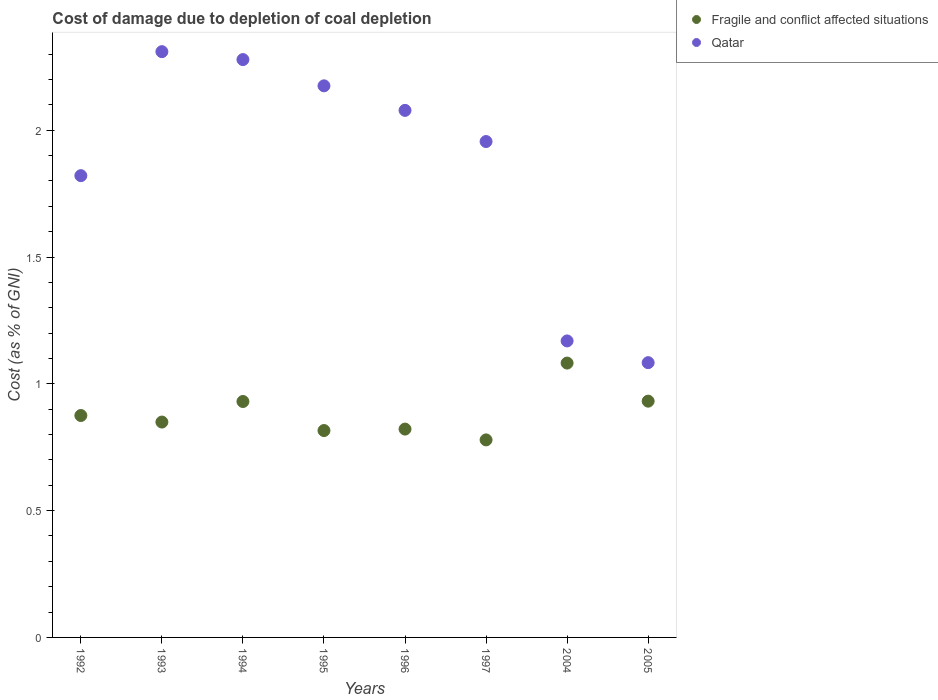How many different coloured dotlines are there?
Keep it short and to the point. 2. What is the cost of damage caused due to coal depletion in Fragile and conflict affected situations in 1994?
Offer a very short reply. 0.93. Across all years, what is the maximum cost of damage caused due to coal depletion in Fragile and conflict affected situations?
Ensure brevity in your answer.  1.08. Across all years, what is the minimum cost of damage caused due to coal depletion in Qatar?
Provide a short and direct response. 1.08. In which year was the cost of damage caused due to coal depletion in Qatar minimum?
Your answer should be compact. 2005. What is the total cost of damage caused due to coal depletion in Fragile and conflict affected situations in the graph?
Offer a very short reply. 7.08. What is the difference between the cost of damage caused due to coal depletion in Qatar in 1992 and that in 1994?
Your answer should be compact. -0.46. What is the difference between the cost of damage caused due to coal depletion in Qatar in 1994 and the cost of damage caused due to coal depletion in Fragile and conflict affected situations in 1992?
Give a very brief answer. 1.4. What is the average cost of damage caused due to coal depletion in Fragile and conflict affected situations per year?
Your response must be concise. 0.89. In the year 2005, what is the difference between the cost of damage caused due to coal depletion in Fragile and conflict affected situations and cost of damage caused due to coal depletion in Qatar?
Your response must be concise. -0.15. In how many years, is the cost of damage caused due to coal depletion in Qatar greater than 0.7 %?
Ensure brevity in your answer.  8. What is the ratio of the cost of damage caused due to coal depletion in Fragile and conflict affected situations in 1994 to that in 1995?
Keep it short and to the point. 1.14. Is the difference between the cost of damage caused due to coal depletion in Fragile and conflict affected situations in 1992 and 2005 greater than the difference between the cost of damage caused due to coal depletion in Qatar in 1992 and 2005?
Your answer should be compact. No. What is the difference between the highest and the second highest cost of damage caused due to coal depletion in Fragile and conflict affected situations?
Provide a short and direct response. 0.15. What is the difference between the highest and the lowest cost of damage caused due to coal depletion in Fragile and conflict affected situations?
Give a very brief answer. 0.3. In how many years, is the cost of damage caused due to coal depletion in Qatar greater than the average cost of damage caused due to coal depletion in Qatar taken over all years?
Your answer should be compact. 5. Is the sum of the cost of damage caused due to coal depletion in Qatar in 1993 and 1997 greater than the maximum cost of damage caused due to coal depletion in Fragile and conflict affected situations across all years?
Provide a succinct answer. Yes. How many years are there in the graph?
Your response must be concise. 8. What is the difference between two consecutive major ticks on the Y-axis?
Your answer should be compact. 0.5. Where does the legend appear in the graph?
Your response must be concise. Top right. What is the title of the graph?
Provide a succinct answer. Cost of damage due to depletion of coal depletion. What is the label or title of the X-axis?
Provide a short and direct response. Years. What is the label or title of the Y-axis?
Make the answer very short. Cost (as % of GNI). What is the Cost (as % of GNI) in Fragile and conflict affected situations in 1992?
Offer a very short reply. 0.88. What is the Cost (as % of GNI) in Qatar in 1992?
Make the answer very short. 1.82. What is the Cost (as % of GNI) of Fragile and conflict affected situations in 1993?
Your answer should be very brief. 0.85. What is the Cost (as % of GNI) of Qatar in 1993?
Offer a terse response. 2.31. What is the Cost (as % of GNI) of Fragile and conflict affected situations in 1994?
Your answer should be very brief. 0.93. What is the Cost (as % of GNI) of Qatar in 1994?
Give a very brief answer. 2.28. What is the Cost (as % of GNI) in Fragile and conflict affected situations in 1995?
Your answer should be compact. 0.82. What is the Cost (as % of GNI) in Qatar in 1995?
Provide a succinct answer. 2.18. What is the Cost (as % of GNI) of Fragile and conflict affected situations in 1996?
Offer a terse response. 0.82. What is the Cost (as % of GNI) in Qatar in 1996?
Make the answer very short. 2.08. What is the Cost (as % of GNI) of Fragile and conflict affected situations in 1997?
Provide a short and direct response. 0.78. What is the Cost (as % of GNI) of Qatar in 1997?
Your answer should be compact. 1.96. What is the Cost (as % of GNI) in Fragile and conflict affected situations in 2004?
Give a very brief answer. 1.08. What is the Cost (as % of GNI) of Qatar in 2004?
Give a very brief answer. 1.17. What is the Cost (as % of GNI) in Fragile and conflict affected situations in 2005?
Your answer should be very brief. 0.93. What is the Cost (as % of GNI) in Qatar in 2005?
Make the answer very short. 1.08. Across all years, what is the maximum Cost (as % of GNI) of Fragile and conflict affected situations?
Provide a succinct answer. 1.08. Across all years, what is the maximum Cost (as % of GNI) of Qatar?
Your answer should be very brief. 2.31. Across all years, what is the minimum Cost (as % of GNI) in Fragile and conflict affected situations?
Make the answer very short. 0.78. Across all years, what is the minimum Cost (as % of GNI) in Qatar?
Offer a terse response. 1.08. What is the total Cost (as % of GNI) of Fragile and conflict affected situations in the graph?
Your answer should be very brief. 7.08. What is the total Cost (as % of GNI) in Qatar in the graph?
Ensure brevity in your answer.  14.87. What is the difference between the Cost (as % of GNI) in Fragile and conflict affected situations in 1992 and that in 1993?
Provide a short and direct response. 0.03. What is the difference between the Cost (as % of GNI) of Qatar in 1992 and that in 1993?
Ensure brevity in your answer.  -0.49. What is the difference between the Cost (as % of GNI) of Fragile and conflict affected situations in 1992 and that in 1994?
Make the answer very short. -0.06. What is the difference between the Cost (as % of GNI) in Qatar in 1992 and that in 1994?
Your answer should be compact. -0.46. What is the difference between the Cost (as % of GNI) in Fragile and conflict affected situations in 1992 and that in 1995?
Your response must be concise. 0.06. What is the difference between the Cost (as % of GNI) of Qatar in 1992 and that in 1995?
Your answer should be very brief. -0.35. What is the difference between the Cost (as % of GNI) of Fragile and conflict affected situations in 1992 and that in 1996?
Offer a terse response. 0.05. What is the difference between the Cost (as % of GNI) in Qatar in 1992 and that in 1996?
Your answer should be very brief. -0.26. What is the difference between the Cost (as % of GNI) in Fragile and conflict affected situations in 1992 and that in 1997?
Ensure brevity in your answer.  0.1. What is the difference between the Cost (as % of GNI) of Qatar in 1992 and that in 1997?
Your answer should be compact. -0.13. What is the difference between the Cost (as % of GNI) in Fragile and conflict affected situations in 1992 and that in 2004?
Provide a succinct answer. -0.21. What is the difference between the Cost (as % of GNI) of Qatar in 1992 and that in 2004?
Make the answer very short. 0.65. What is the difference between the Cost (as % of GNI) in Fragile and conflict affected situations in 1992 and that in 2005?
Ensure brevity in your answer.  -0.06. What is the difference between the Cost (as % of GNI) of Qatar in 1992 and that in 2005?
Provide a short and direct response. 0.74. What is the difference between the Cost (as % of GNI) in Fragile and conflict affected situations in 1993 and that in 1994?
Offer a very short reply. -0.08. What is the difference between the Cost (as % of GNI) in Qatar in 1993 and that in 1994?
Your response must be concise. 0.03. What is the difference between the Cost (as % of GNI) in Fragile and conflict affected situations in 1993 and that in 1995?
Your response must be concise. 0.03. What is the difference between the Cost (as % of GNI) in Qatar in 1993 and that in 1995?
Ensure brevity in your answer.  0.13. What is the difference between the Cost (as % of GNI) in Fragile and conflict affected situations in 1993 and that in 1996?
Offer a very short reply. 0.03. What is the difference between the Cost (as % of GNI) of Qatar in 1993 and that in 1996?
Give a very brief answer. 0.23. What is the difference between the Cost (as % of GNI) of Fragile and conflict affected situations in 1993 and that in 1997?
Provide a short and direct response. 0.07. What is the difference between the Cost (as % of GNI) of Qatar in 1993 and that in 1997?
Make the answer very short. 0.35. What is the difference between the Cost (as % of GNI) of Fragile and conflict affected situations in 1993 and that in 2004?
Ensure brevity in your answer.  -0.23. What is the difference between the Cost (as % of GNI) of Qatar in 1993 and that in 2004?
Your answer should be compact. 1.14. What is the difference between the Cost (as % of GNI) in Fragile and conflict affected situations in 1993 and that in 2005?
Give a very brief answer. -0.08. What is the difference between the Cost (as % of GNI) in Qatar in 1993 and that in 2005?
Keep it short and to the point. 1.23. What is the difference between the Cost (as % of GNI) in Fragile and conflict affected situations in 1994 and that in 1995?
Offer a terse response. 0.11. What is the difference between the Cost (as % of GNI) of Qatar in 1994 and that in 1995?
Keep it short and to the point. 0.1. What is the difference between the Cost (as % of GNI) in Fragile and conflict affected situations in 1994 and that in 1996?
Provide a succinct answer. 0.11. What is the difference between the Cost (as % of GNI) in Qatar in 1994 and that in 1996?
Your response must be concise. 0.2. What is the difference between the Cost (as % of GNI) in Fragile and conflict affected situations in 1994 and that in 1997?
Make the answer very short. 0.15. What is the difference between the Cost (as % of GNI) in Qatar in 1994 and that in 1997?
Your response must be concise. 0.32. What is the difference between the Cost (as % of GNI) of Fragile and conflict affected situations in 1994 and that in 2004?
Offer a terse response. -0.15. What is the difference between the Cost (as % of GNI) of Qatar in 1994 and that in 2004?
Offer a very short reply. 1.11. What is the difference between the Cost (as % of GNI) in Fragile and conflict affected situations in 1994 and that in 2005?
Your answer should be compact. -0. What is the difference between the Cost (as % of GNI) of Qatar in 1994 and that in 2005?
Provide a short and direct response. 1.2. What is the difference between the Cost (as % of GNI) in Fragile and conflict affected situations in 1995 and that in 1996?
Provide a succinct answer. -0.01. What is the difference between the Cost (as % of GNI) of Qatar in 1995 and that in 1996?
Offer a terse response. 0.1. What is the difference between the Cost (as % of GNI) in Fragile and conflict affected situations in 1995 and that in 1997?
Keep it short and to the point. 0.04. What is the difference between the Cost (as % of GNI) of Qatar in 1995 and that in 1997?
Your answer should be compact. 0.22. What is the difference between the Cost (as % of GNI) of Fragile and conflict affected situations in 1995 and that in 2004?
Keep it short and to the point. -0.27. What is the difference between the Cost (as % of GNI) in Qatar in 1995 and that in 2004?
Provide a succinct answer. 1.01. What is the difference between the Cost (as % of GNI) in Fragile and conflict affected situations in 1995 and that in 2005?
Your answer should be very brief. -0.12. What is the difference between the Cost (as % of GNI) of Qatar in 1995 and that in 2005?
Your answer should be compact. 1.09. What is the difference between the Cost (as % of GNI) of Fragile and conflict affected situations in 1996 and that in 1997?
Provide a short and direct response. 0.04. What is the difference between the Cost (as % of GNI) of Qatar in 1996 and that in 1997?
Provide a short and direct response. 0.12. What is the difference between the Cost (as % of GNI) of Fragile and conflict affected situations in 1996 and that in 2004?
Your answer should be very brief. -0.26. What is the difference between the Cost (as % of GNI) in Qatar in 1996 and that in 2004?
Make the answer very short. 0.91. What is the difference between the Cost (as % of GNI) in Fragile and conflict affected situations in 1996 and that in 2005?
Your response must be concise. -0.11. What is the difference between the Cost (as % of GNI) of Qatar in 1996 and that in 2005?
Your response must be concise. 0.99. What is the difference between the Cost (as % of GNI) in Fragile and conflict affected situations in 1997 and that in 2004?
Your answer should be compact. -0.3. What is the difference between the Cost (as % of GNI) of Qatar in 1997 and that in 2004?
Make the answer very short. 0.79. What is the difference between the Cost (as % of GNI) of Fragile and conflict affected situations in 1997 and that in 2005?
Your response must be concise. -0.15. What is the difference between the Cost (as % of GNI) of Qatar in 1997 and that in 2005?
Offer a terse response. 0.87. What is the difference between the Cost (as % of GNI) in Fragile and conflict affected situations in 2004 and that in 2005?
Provide a succinct answer. 0.15. What is the difference between the Cost (as % of GNI) in Qatar in 2004 and that in 2005?
Your response must be concise. 0.09. What is the difference between the Cost (as % of GNI) of Fragile and conflict affected situations in 1992 and the Cost (as % of GNI) of Qatar in 1993?
Give a very brief answer. -1.43. What is the difference between the Cost (as % of GNI) in Fragile and conflict affected situations in 1992 and the Cost (as % of GNI) in Qatar in 1994?
Make the answer very short. -1.4. What is the difference between the Cost (as % of GNI) in Fragile and conflict affected situations in 1992 and the Cost (as % of GNI) in Qatar in 1996?
Your response must be concise. -1.2. What is the difference between the Cost (as % of GNI) of Fragile and conflict affected situations in 1992 and the Cost (as % of GNI) of Qatar in 1997?
Offer a terse response. -1.08. What is the difference between the Cost (as % of GNI) of Fragile and conflict affected situations in 1992 and the Cost (as % of GNI) of Qatar in 2004?
Keep it short and to the point. -0.29. What is the difference between the Cost (as % of GNI) of Fragile and conflict affected situations in 1992 and the Cost (as % of GNI) of Qatar in 2005?
Provide a short and direct response. -0.21. What is the difference between the Cost (as % of GNI) of Fragile and conflict affected situations in 1993 and the Cost (as % of GNI) of Qatar in 1994?
Ensure brevity in your answer.  -1.43. What is the difference between the Cost (as % of GNI) in Fragile and conflict affected situations in 1993 and the Cost (as % of GNI) in Qatar in 1995?
Your answer should be compact. -1.33. What is the difference between the Cost (as % of GNI) of Fragile and conflict affected situations in 1993 and the Cost (as % of GNI) of Qatar in 1996?
Ensure brevity in your answer.  -1.23. What is the difference between the Cost (as % of GNI) of Fragile and conflict affected situations in 1993 and the Cost (as % of GNI) of Qatar in 1997?
Provide a succinct answer. -1.11. What is the difference between the Cost (as % of GNI) in Fragile and conflict affected situations in 1993 and the Cost (as % of GNI) in Qatar in 2004?
Ensure brevity in your answer.  -0.32. What is the difference between the Cost (as % of GNI) in Fragile and conflict affected situations in 1993 and the Cost (as % of GNI) in Qatar in 2005?
Provide a short and direct response. -0.23. What is the difference between the Cost (as % of GNI) in Fragile and conflict affected situations in 1994 and the Cost (as % of GNI) in Qatar in 1995?
Make the answer very short. -1.24. What is the difference between the Cost (as % of GNI) in Fragile and conflict affected situations in 1994 and the Cost (as % of GNI) in Qatar in 1996?
Provide a short and direct response. -1.15. What is the difference between the Cost (as % of GNI) of Fragile and conflict affected situations in 1994 and the Cost (as % of GNI) of Qatar in 1997?
Ensure brevity in your answer.  -1.03. What is the difference between the Cost (as % of GNI) of Fragile and conflict affected situations in 1994 and the Cost (as % of GNI) of Qatar in 2004?
Ensure brevity in your answer.  -0.24. What is the difference between the Cost (as % of GNI) of Fragile and conflict affected situations in 1994 and the Cost (as % of GNI) of Qatar in 2005?
Provide a succinct answer. -0.15. What is the difference between the Cost (as % of GNI) in Fragile and conflict affected situations in 1995 and the Cost (as % of GNI) in Qatar in 1996?
Your response must be concise. -1.26. What is the difference between the Cost (as % of GNI) of Fragile and conflict affected situations in 1995 and the Cost (as % of GNI) of Qatar in 1997?
Make the answer very short. -1.14. What is the difference between the Cost (as % of GNI) in Fragile and conflict affected situations in 1995 and the Cost (as % of GNI) in Qatar in 2004?
Provide a succinct answer. -0.35. What is the difference between the Cost (as % of GNI) in Fragile and conflict affected situations in 1995 and the Cost (as % of GNI) in Qatar in 2005?
Provide a succinct answer. -0.27. What is the difference between the Cost (as % of GNI) in Fragile and conflict affected situations in 1996 and the Cost (as % of GNI) in Qatar in 1997?
Your answer should be very brief. -1.13. What is the difference between the Cost (as % of GNI) in Fragile and conflict affected situations in 1996 and the Cost (as % of GNI) in Qatar in 2004?
Make the answer very short. -0.35. What is the difference between the Cost (as % of GNI) of Fragile and conflict affected situations in 1996 and the Cost (as % of GNI) of Qatar in 2005?
Provide a short and direct response. -0.26. What is the difference between the Cost (as % of GNI) of Fragile and conflict affected situations in 1997 and the Cost (as % of GNI) of Qatar in 2004?
Make the answer very short. -0.39. What is the difference between the Cost (as % of GNI) in Fragile and conflict affected situations in 1997 and the Cost (as % of GNI) in Qatar in 2005?
Provide a succinct answer. -0.3. What is the difference between the Cost (as % of GNI) of Fragile and conflict affected situations in 2004 and the Cost (as % of GNI) of Qatar in 2005?
Make the answer very short. -0. What is the average Cost (as % of GNI) of Fragile and conflict affected situations per year?
Your answer should be very brief. 0.89. What is the average Cost (as % of GNI) in Qatar per year?
Keep it short and to the point. 1.86. In the year 1992, what is the difference between the Cost (as % of GNI) of Fragile and conflict affected situations and Cost (as % of GNI) of Qatar?
Give a very brief answer. -0.95. In the year 1993, what is the difference between the Cost (as % of GNI) in Fragile and conflict affected situations and Cost (as % of GNI) in Qatar?
Offer a very short reply. -1.46. In the year 1994, what is the difference between the Cost (as % of GNI) of Fragile and conflict affected situations and Cost (as % of GNI) of Qatar?
Your answer should be very brief. -1.35. In the year 1995, what is the difference between the Cost (as % of GNI) of Fragile and conflict affected situations and Cost (as % of GNI) of Qatar?
Your answer should be very brief. -1.36. In the year 1996, what is the difference between the Cost (as % of GNI) in Fragile and conflict affected situations and Cost (as % of GNI) in Qatar?
Give a very brief answer. -1.26. In the year 1997, what is the difference between the Cost (as % of GNI) in Fragile and conflict affected situations and Cost (as % of GNI) in Qatar?
Your answer should be compact. -1.18. In the year 2004, what is the difference between the Cost (as % of GNI) in Fragile and conflict affected situations and Cost (as % of GNI) in Qatar?
Make the answer very short. -0.09. In the year 2005, what is the difference between the Cost (as % of GNI) of Fragile and conflict affected situations and Cost (as % of GNI) of Qatar?
Offer a very short reply. -0.15. What is the ratio of the Cost (as % of GNI) in Fragile and conflict affected situations in 1992 to that in 1993?
Ensure brevity in your answer.  1.03. What is the ratio of the Cost (as % of GNI) in Qatar in 1992 to that in 1993?
Keep it short and to the point. 0.79. What is the ratio of the Cost (as % of GNI) in Fragile and conflict affected situations in 1992 to that in 1994?
Keep it short and to the point. 0.94. What is the ratio of the Cost (as % of GNI) in Qatar in 1992 to that in 1994?
Your answer should be very brief. 0.8. What is the ratio of the Cost (as % of GNI) of Fragile and conflict affected situations in 1992 to that in 1995?
Ensure brevity in your answer.  1.07. What is the ratio of the Cost (as % of GNI) in Qatar in 1992 to that in 1995?
Make the answer very short. 0.84. What is the ratio of the Cost (as % of GNI) of Fragile and conflict affected situations in 1992 to that in 1996?
Your answer should be compact. 1.07. What is the ratio of the Cost (as % of GNI) of Qatar in 1992 to that in 1996?
Ensure brevity in your answer.  0.88. What is the ratio of the Cost (as % of GNI) of Fragile and conflict affected situations in 1992 to that in 1997?
Offer a terse response. 1.12. What is the ratio of the Cost (as % of GNI) in Qatar in 1992 to that in 1997?
Ensure brevity in your answer.  0.93. What is the ratio of the Cost (as % of GNI) in Fragile and conflict affected situations in 1992 to that in 2004?
Keep it short and to the point. 0.81. What is the ratio of the Cost (as % of GNI) of Qatar in 1992 to that in 2004?
Ensure brevity in your answer.  1.56. What is the ratio of the Cost (as % of GNI) of Fragile and conflict affected situations in 1992 to that in 2005?
Make the answer very short. 0.94. What is the ratio of the Cost (as % of GNI) of Qatar in 1992 to that in 2005?
Your answer should be very brief. 1.68. What is the ratio of the Cost (as % of GNI) of Fragile and conflict affected situations in 1993 to that in 1994?
Your answer should be very brief. 0.91. What is the ratio of the Cost (as % of GNI) in Qatar in 1993 to that in 1994?
Give a very brief answer. 1.01. What is the ratio of the Cost (as % of GNI) of Fragile and conflict affected situations in 1993 to that in 1995?
Offer a terse response. 1.04. What is the ratio of the Cost (as % of GNI) in Qatar in 1993 to that in 1995?
Provide a succinct answer. 1.06. What is the ratio of the Cost (as % of GNI) of Fragile and conflict affected situations in 1993 to that in 1996?
Offer a very short reply. 1.03. What is the ratio of the Cost (as % of GNI) of Qatar in 1993 to that in 1996?
Your answer should be compact. 1.11. What is the ratio of the Cost (as % of GNI) in Fragile and conflict affected situations in 1993 to that in 1997?
Keep it short and to the point. 1.09. What is the ratio of the Cost (as % of GNI) in Qatar in 1993 to that in 1997?
Make the answer very short. 1.18. What is the ratio of the Cost (as % of GNI) in Fragile and conflict affected situations in 1993 to that in 2004?
Offer a terse response. 0.79. What is the ratio of the Cost (as % of GNI) in Qatar in 1993 to that in 2004?
Ensure brevity in your answer.  1.98. What is the ratio of the Cost (as % of GNI) of Fragile and conflict affected situations in 1993 to that in 2005?
Keep it short and to the point. 0.91. What is the ratio of the Cost (as % of GNI) of Qatar in 1993 to that in 2005?
Keep it short and to the point. 2.13. What is the ratio of the Cost (as % of GNI) in Fragile and conflict affected situations in 1994 to that in 1995?
Your answer should be compact. 1.14. What is the ratio of the Cost (as % of GNI) in Qatar in 1994 to that in 1995?
Offer a terse response. 1.05. What is the ratio of the Cost (as % of GNI) in Fragile and conflict affected situations in 1994 to that in 1996?
Your answer should be compact. 1.13. What is the ratio of the Cost (as % of GNI) in Qatar in 1994 to that in 1996?
Your response must be concise. 1.1. What is the ratio of the Cost (as % of GNI) in Fragile and conflict affected situations in 1994 to that in 1997?
Offer a very short reply. 1.19. What is the ratio of the Cost (as % of GNI) in Qatar in 1994 to that in 1997?
Offer a terse response. 1.17. What is the ratio of the Cost (as % of GNI) in Fragile and conflict affected situations in 1994 to that in 2004?
Offer a terse response. 0.86. What is the ratio of the Cost (as % of GNI) of Qatar in 1994 to that in 2004?
Your response must be concise. 1.95. What is the ratio of the Cost (as % of GNI) in Fragile and conflict affected situations in 1994 to that in 2005?
Your answer should be very brief. 1. What is the ratio of the Cost (as % of GNI) of Qatar in 1994 to that in 2005?
Provide a short and direct response. 2.1. What is the ratio of the Cost (as % of GNI) of Qatar in 1995 to that in 1996?
Keep it short and to the point. 1.05. What is the ratio of the Cost (as % of GNI) of Fragile and conflict affected situations in 1995 to that in 1997?
Your answer should be very brief. 1.05. What is the ratio of the Cost (as % of GNI) of Qatar in 1995 to that in 1997?
Make the answer very short. 1.11. What is the ratio of the Cost (as % of GNI) in Fragile and conflict affected situations in 1995 to that in 2004?
Your response must be concise. 0.75. What is the ratio of the Cost (as % of GNI) in Qatar in 1995 to that in 2004?
Your answer should be compact. 1.86. What is the ratio of the Cost (as % of GNI) of Fragile and conflict affected situations in 1995 to that in 2005?
Offer a very short reply. 0.88. What is the ratio of the Cost (as % of GNI) in Qatar in 1995 to that in 2005?
Offer a terse response. 2.01. What is the ratio of the Cost (as % of GNI) of Fragile and conflict affected situations in 1996 to that in 1997?
Your response must be concise. 1.05. What is the ratio of the Cost (as % of GNI) of Qatar in 1996 to that in 1997?
Offer a terse response. 1.06. What is the ratio of the Cost (as % of GNI) in Fragile and conflict affected situations in 1996 to that in 2004?
Offer a terse response. 0.76. What is the ratio of the Cost (as % of GNI) of Qatar in 1996 to that in 2004?
Your response must be concise. 1.78. What is the ratio of the Cost (as % of GNI) in Fragile and conflict affected situations in 1996 to that in 2005?
Your response must be concise. 0.88. What is the ratio of the Cost (as % of GNI) in Qatar in 1996 to that in 2005?
Your answer should be very brief. 1.92. What is the ratio of the Cost (as % of GNI) in Fragile and conflict affected situations in 1997 to that in 2004?
Offer a terse response. 0.72. What is the ratio of the Cost (as % of GNI) in Qatar in 1997 to that in 2004?
Your answer should be very brief. 1.67. What is the ratio of the Cost (as % of GNI) in Fragile and conflict affected situations in 1997 to that in 2005?
Keep it short and to the point. 0.84. What is the ratio of the Cost (as % of GNI) of Qatar in 1997 to that in 2005?
Make the answer very short. 1.8. What is the ratio of the Cost (as % of GNI) in Fragile and conflict affected situations in 2004 to that in 2005?
Ensure brevity in your answer.  1.16. What is the ratio of the Cost (as % of GNI) in Qatar in 2004 to that in 2005?
Make the answer very short. 1.08. What is the difference between the highest and the second highest Cost (as % of GNI) of Fragile and conflict affected situations?
Provide a succinct answer. 0.15. What is the difference between the highest and the second highest Cost (as % of GNI) in Qatar?
Your response must be concise. 0.03. What is the difference between the highest and the lowest Cost (as % of GNI) of Fragile and conflict affected situations?
Your answer should be compact. 0.3. What is the difference between the highest and the lowest Cost (as % of GNI) of Qatar?
Your answer should be compact. 1.23. 